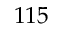<formula> <loc_0><loc_0><loc_500><loc_500>1 1 5</formula> 